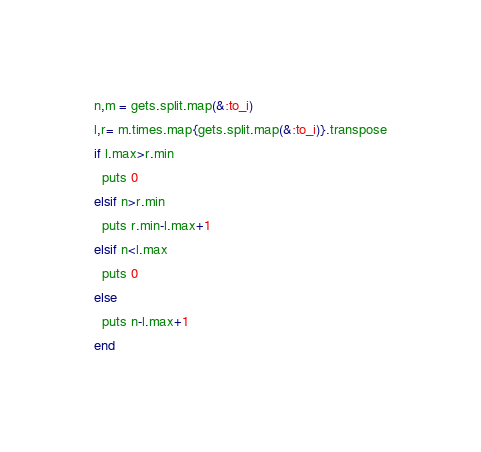<code> <loc_0><loc_0><loc_500><loc_500><_Ruby_>n,m = gets.split.map(&:to_i)
l,r= m.times.map{gets.split.map(&:to_i)}.transpose
if l.max>r.min
  puts 0
elsif n>r.min
  puts r.min-l.max+1
elsif n<l.max
  puts 0
else
  puts n-l.max+1
end</code> 